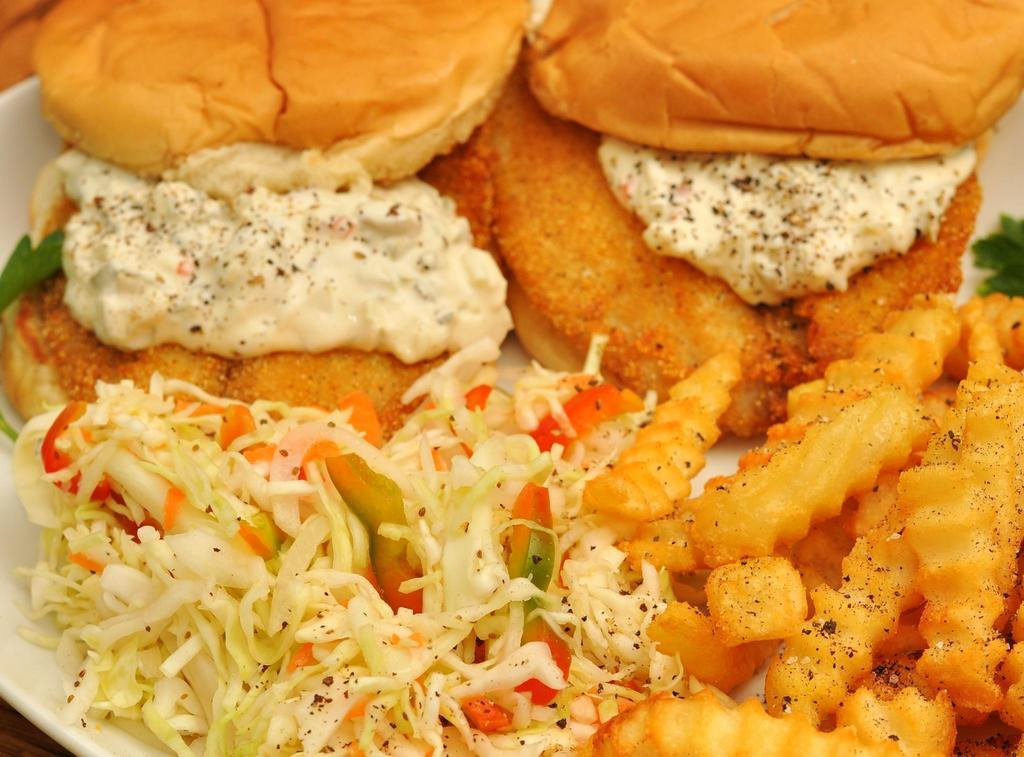What is on the white plate in the image? There is food on a white plate in the image. Can you describe the object in the top left side corner of the image? Unfortunately, the provided facts do not give enough information to describe the object in the top left side corner of the image. How many jellyfish are swimming in the food on the plate? There are no jellyfish present in the image, as the facts only mention food on a white plate. Is there a crown on the plate with the food? The provided facts do not mention a crown or any other specific details about the food on the plate, so it cannot be determined from the image. 